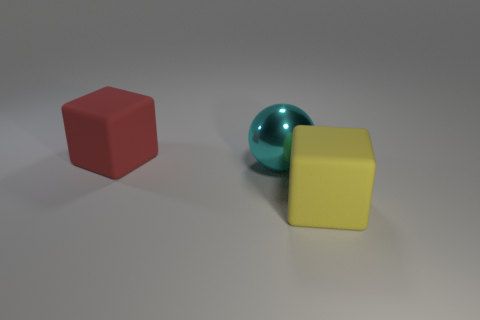Are there any other things that have the same material as the large cyan object?
Your answer should be compact. No. What number of things are either green matte things or blocks that are to the right of the big cyan thing?
Ensure brevity in your answer.  1. The large rubber thing to the left of the yellow block is what color?
Provide a short and direct response. Red. What is the shape of the yellow rubber thing?
Provide a short and direct response. Cube. What is the material of the large block left of the big block in front of the big red cube?
Your answer should be compact. Rubber. How many other objects are there of the same material as the large yellow cube?
Keep it short and to the point. 1. There is a cyan thing that is the same size as the yellow rubber object; what is it made of?
Provide a succinct answer. Metal. Is the number of red objects that are on the left side of the big yellow cube greater than the number of large cyan things on the left side of the large shiny ball?
Ensure brevity in your answer.  Yes. Is there another rubber thing of the same shape as the big red matte object?
Provide a short and direct response. Yes. What is the shape of the red object that is the same size as the cyan sphere?
Provide a succinct answer. Cube. 